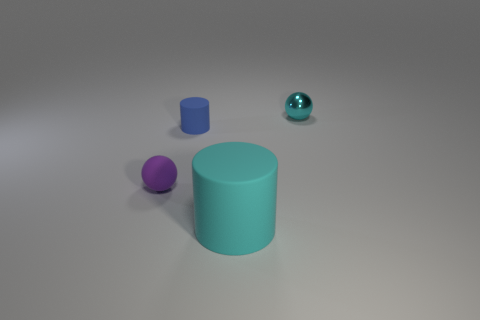Add 2 tiny purple rubber cylinders. How many objects exist? 6 Subtract all purple spheres. How many spheres are left? 1 Subtract all cyan shiny objects. Subtract all matte cylinders. How many objects are left? 1 Add 4 tiny blue cylinders. How many tiny blue cylinders are left? 5 Add 2 rubber cylinders. How many rubber cylinders exist? 4 Subtract 0 red cylinders. How many objects are left? 4 Subtract all cyan spheres. Subtract all yellow blocks. How many spheres are left? 1 